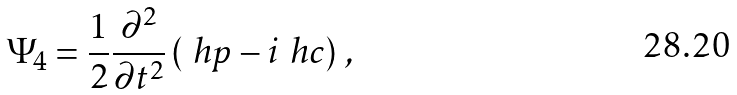Convert formula to latex. <formula><loc_0><loc_0><loc_500><loc_500>\Psi _ { 4 } = \frac { 1 } { 2 } \frac { \partial ^ { 2 } } { \partial t ^ { 2 } } \left ( \ h p - i \ h c \right ) \, ,</formula> 